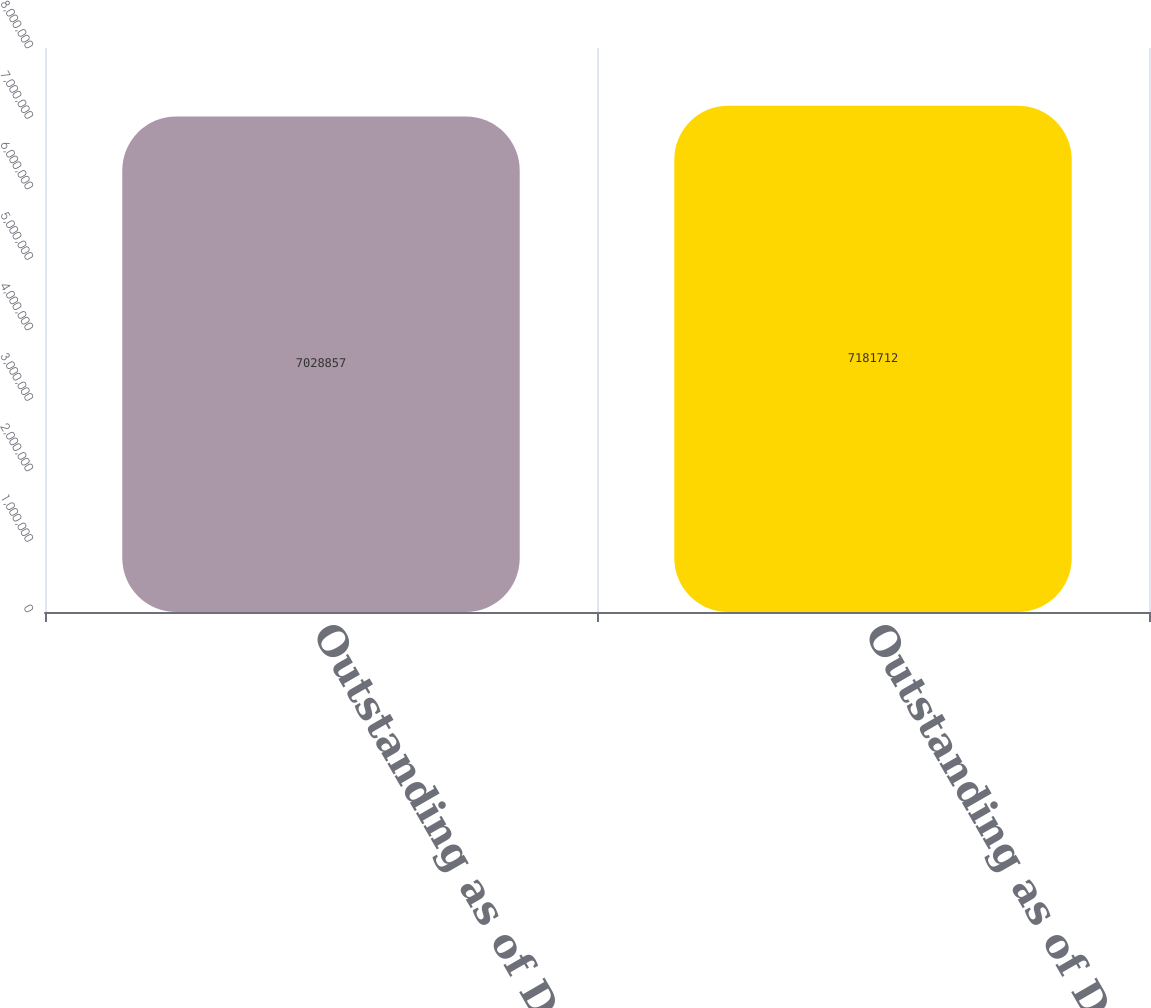<chart> <loc_0><loc_0><loc_500><loc_500><bar_chart><fcel>Outstanding as of December 25<fcel>Outstanding as of December 31<nl><fcel>7.02886e+06<fcel>7.18171e+06<nl></chart> 